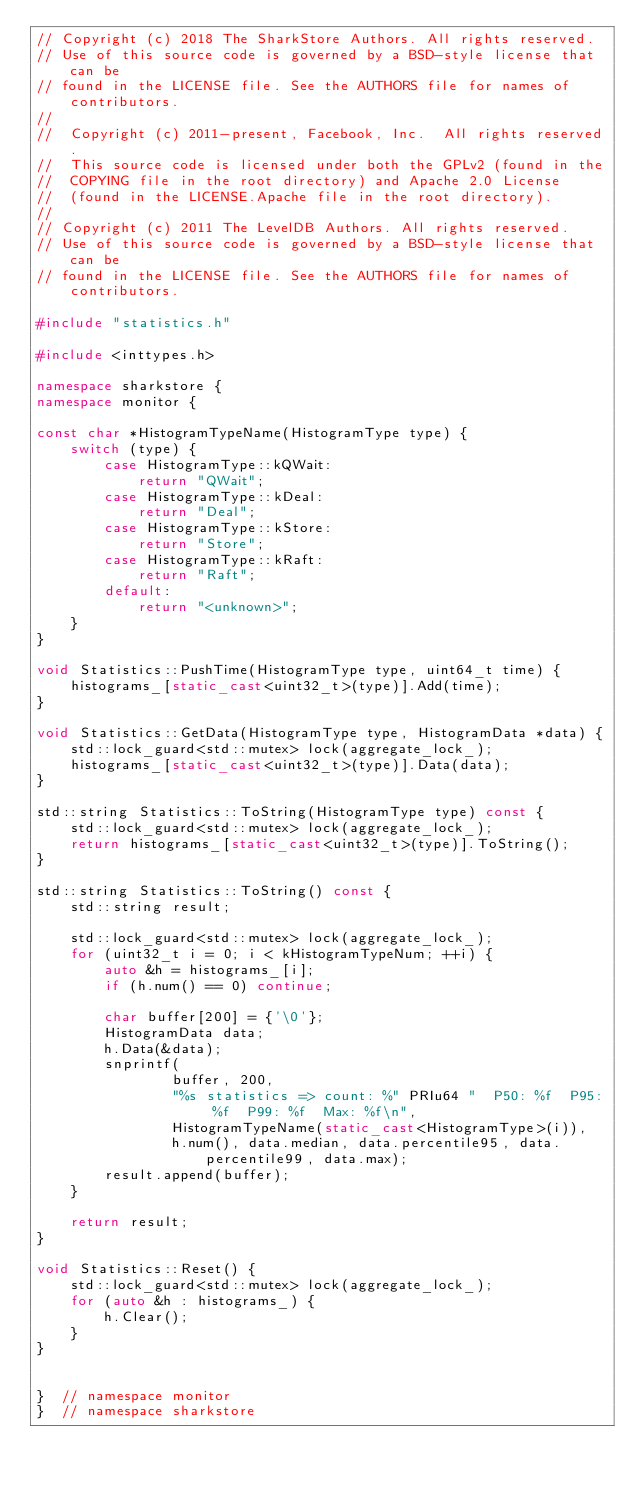Convert code to text. <code><loc_0><loc_0><loc_500><loc_500><_C++_>// Copyright (c) 2018 The SharkStore Authors. All rights reserved.
// Use of this source code is governed by a BSD-style license that can be
// found in the LICENSE file. See the AUTHORS file for names of contributors.
//
//  Copyright (c) 2011-present, Facebook, Inc.  All rights reserved.
//  This source code is licensed under both the GPLv2 (found in the
//  COPYING file in the root directory) and Apache 2.0 License
//  (found in the LICENSE.Apache file in the root directory).
//
// Copyright (c) 2011 The LevelDB Authors. All rights reserved.
// Use of this source code is governed by a BSD-style license that can be
// found in the LICENSE file. See the AUTHORS file for names of contributors.

#include "statistics.h"

#include <inttypes.h>

namespace sharkstore {
namespace monitor {

const char *HistogramTypeName(HistogramType type) {
    switch (type) {
        case HistogramType::kQWait:
            return "QWait";
        case HistogramType::kDeal:
            return "Deal";
        case HistogramType::kStore:
            return "Store";
        case HistogramType::kRaft:
            return "Raft";
        default:
            return "<unknown>";
    }
}

void Statistics::PushTime(HistogramType type, uint64_t time) {
    histograms_[static_cast<uint32_t>(type)].Add(time);
}

void Statistics::GetData(HistogramType type, HistogramData *data) {
    std::lock_guard<std::mutex> lock(aggregate_lock_);
    histograms_[static_cast<uint32_t>(type)].Data(data);
}

std::string Statistics::ToString(HistogramType type) const {
    std::lock_guard<std::mutex> lock(aggregate_lock_);
    return histograms_[static_cast<uint32_t>(type)].ToString();
}

std::string Statistics::ToString() const {
    std::string result;

    std::lock_guard<std::mutex> lock(aggregate_lock_);
    for (uint32_t i = 0; i < kHistogramTypeNum; ++i) {
        auto &h = histograms_[i];
        if (h.num() == 0) continue;

        char buffer[200] = {'\0'};
        HistogramData data;
        h.Data(&data);
        snprintf(
                buffer, 200,
                "%s statistics => count: %" PRIu64 "  P50: %f  P95: %f  P99: %f  Max: %f\n",
                HistogramTypeName(static_cast<HistogramType>(i)),
                h.num(), data.median, data.percentile95, data.percentile99, data.max);
        result.append(buffer);
    }

    return result;
}

void Statistics::Reset() {
    std::lock_guard<std::mutex> lock(aggregate_lock_);
    for (auto &h : histograms_) {
        h.Clear();
    }
}


}  // namespace monitor
}  // namespace sharkstore
</code> 